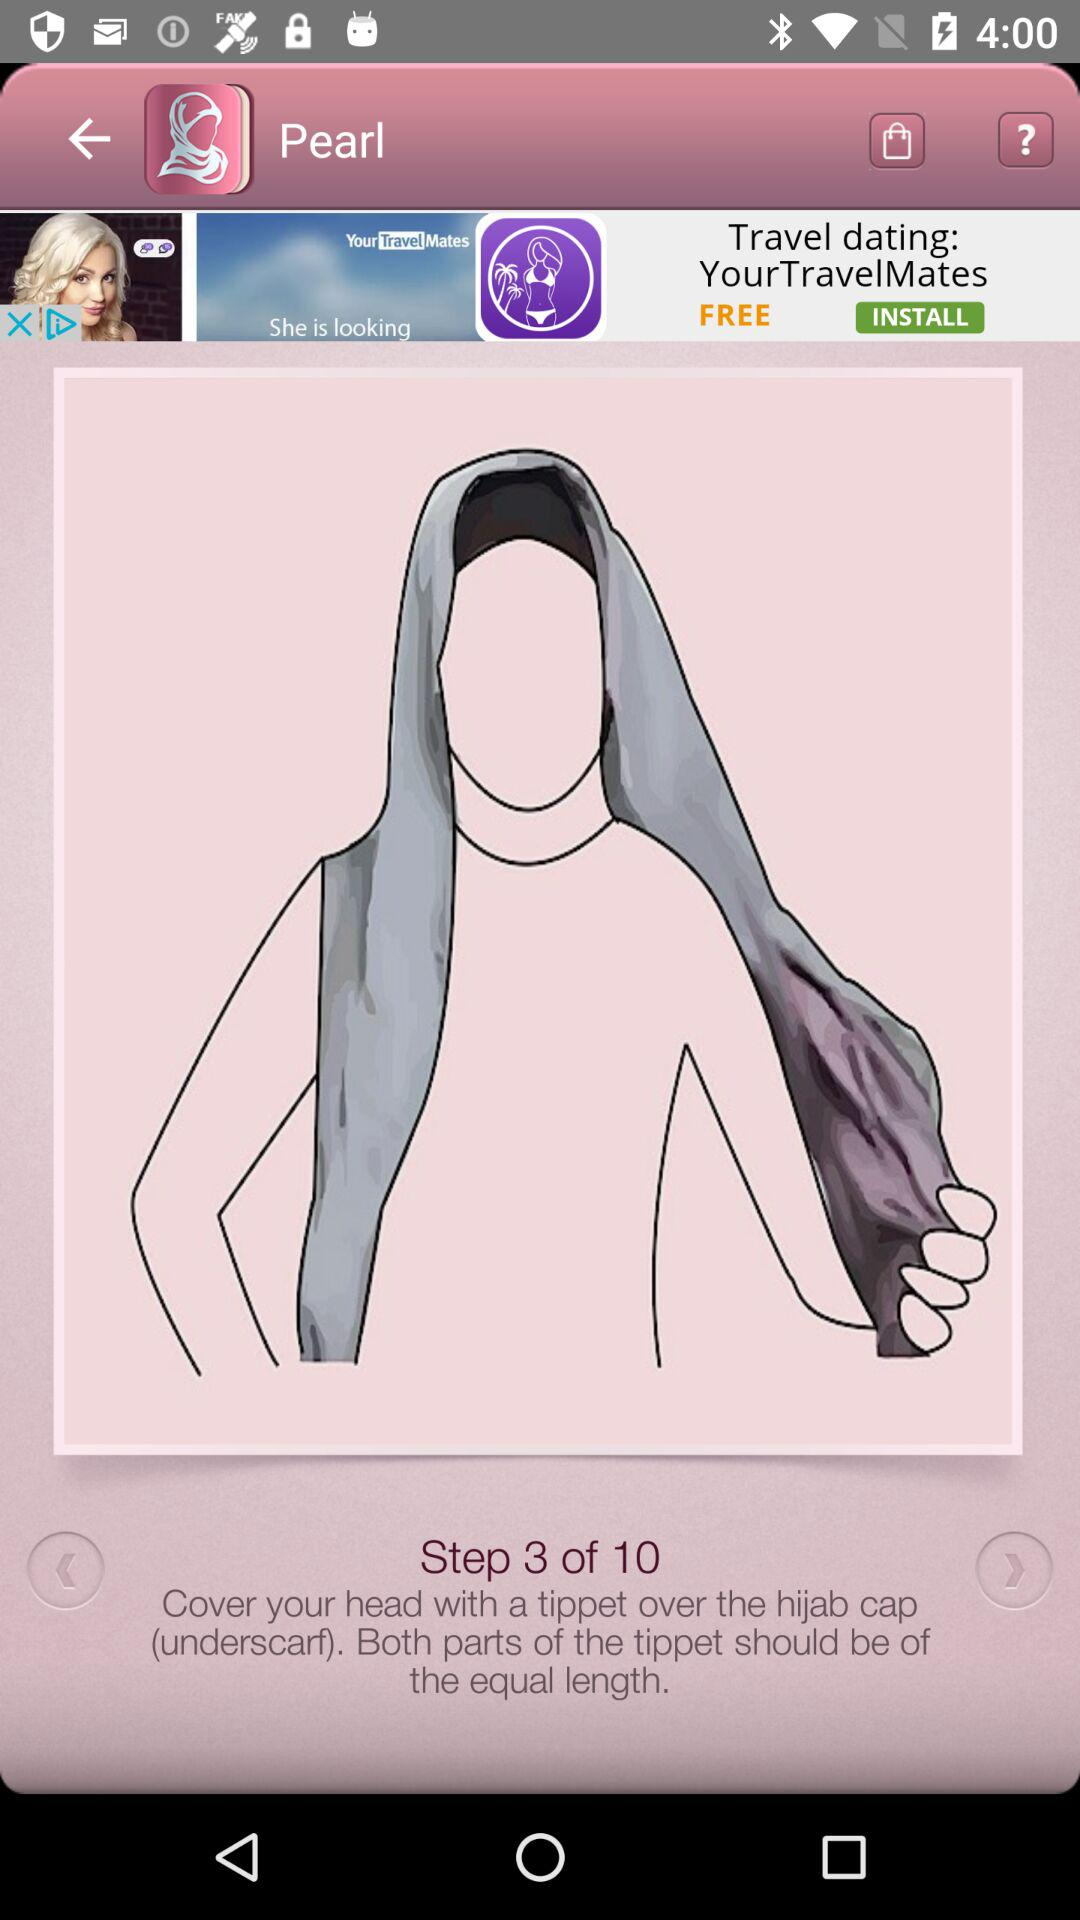How many steps are there in the tutorial?
Answer the question using a single word or phrase. 10 